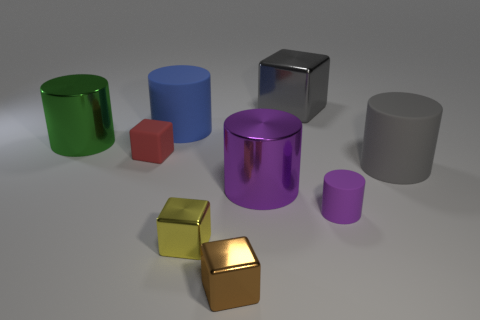How many tiny purple rubber objects are behind the large green metal object?
Your answer should be compact. 0. Is there another big metallic cube that has the same color as the large metallic block?
Your answer should be very brief. No. What shape is the blue rubber thing that is the same size as the gray cylinder?
Make the answer very short. Cylinder. How many cyan objects are either metallic things or tiny blocks?
Your answer should be compact. 0. How many shiny things are the same size as the red matte object?
Your response must be concise. 2. There is a shiny object that is the same color as the small cylinder; what shape is it?
Your answer should be compact. Cylinder. What number of objects are either big matte objects or cylinders on the left side of the blue matte cylinder?
Keep it short and to the point. 3. There is a blue rubber cylinder that is to the left of the brown shiny cube; is it the same size as the purple cylinder that is in front of the large purple shiny cylinder?
Your response must be concise. No. How many big blue objects have the same shape as the green object?
Your answer should be compact. 1. The small red thing that is the same material as the large gray cylinder is what shape?
Your answer should be very brief. Cube. 